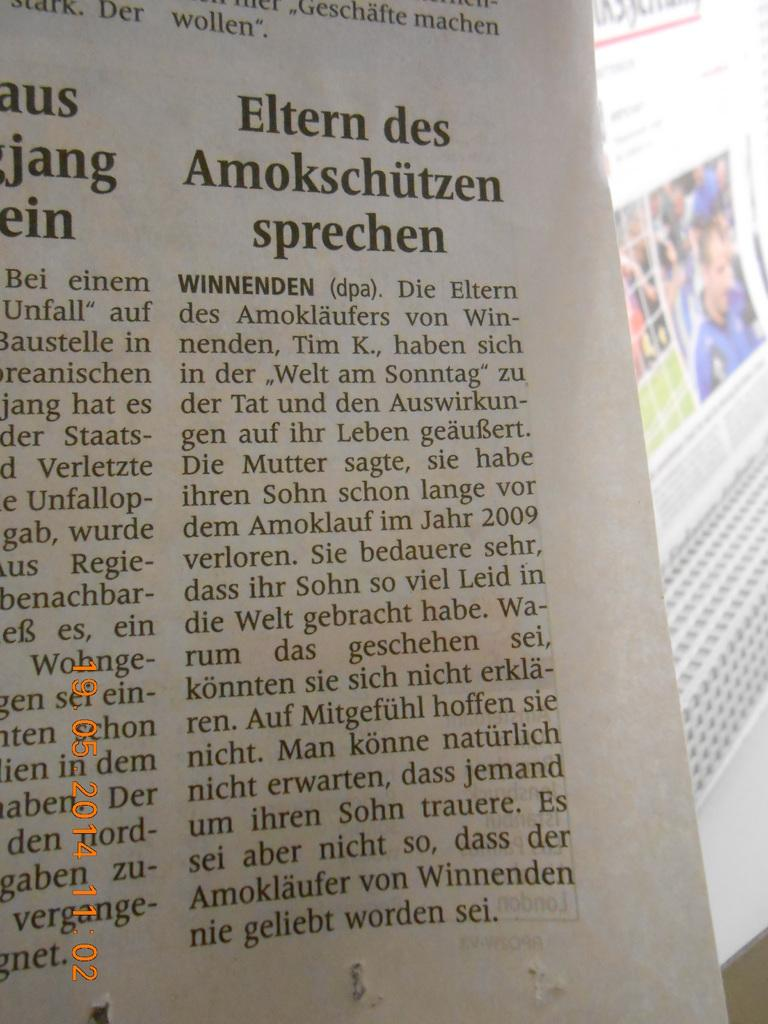<image>
Summarize the visual content of the image. A section of a newspaper with the headline Eltern des Amokschützen sprechen. 